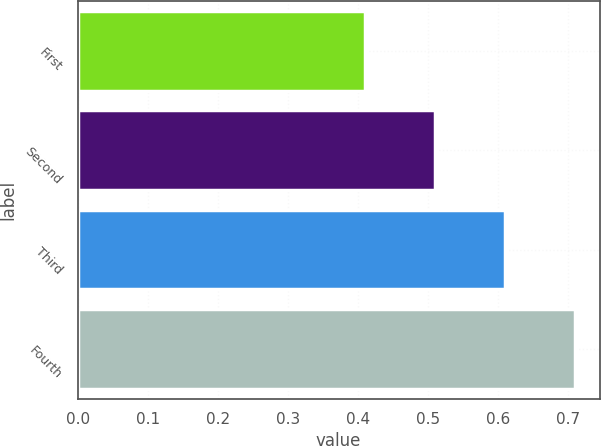Convert chart. <chart><loc_0><loc_0><loc_500><loc_500><bar_chart><fcel>First<fcel>Second<fcel>Third<fcel>Fourth<nl><fcel>0.41<fcel>0.51<fcel>0.61<fcel>0.71<nl></chart> 